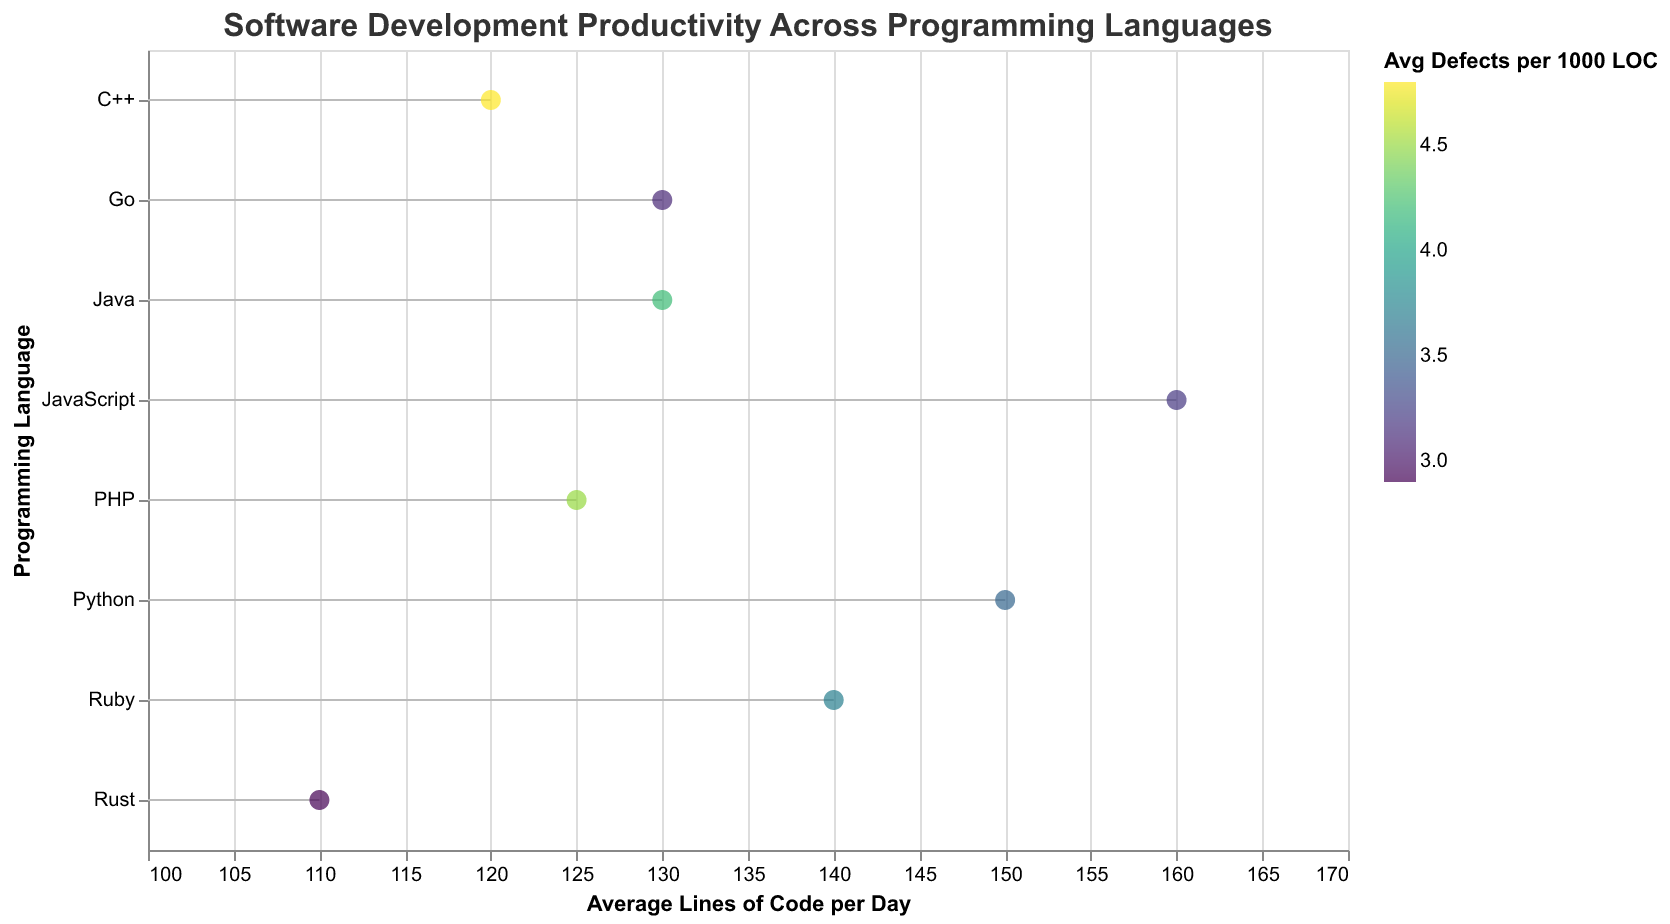What is the title of the plot? The title of the plot is usually found at the top of the figure. In this case, it is specified as "Software Development Productivity Across Programming Languages".
Answer: Software Development Productivity Across Programming Languages Which programming language has the highest average lines of code per day? From the plot, locate the programming language associated with the highest value on the x-axis ("Average Lines of Code per Day"). The highest value here is 160, which corresponds to JavaScript.
Answer: JavaScript Which programming language has the lowest average defects per 1000 lines of code? Look at the color legend associated with "Average Defects per 1000 Lines of Code" and find the programming language with the darkest color. Rust has the lowest defects at 2.9 per 1000 lines of code.
Answer: Rust What is the average years of experience for developers using Python? The years of experience for Python, provided in the tooltip, is 5 years.
Answer: 5 How does the productivity of Python developers compare to that of Java developers in terms of average lines of code per day? Compare the "Average Lines of Code per Day" for Python and Java by looking at their respective positions on the x-axis. Python developers have 150 lines per day, while Java developers have 130 lines per day.
Answer: Python developers are more productive with 150 lines per day compared to Java developers with 130 lines per day Which company shows the highest average lines of code per day among its developers, and what is the corresponding programming language? Look for the data point farthest to the right on the x-axis and refer to the tooltip to identify the related company and programming language. Amazon and JavaScript are associated with the highest productivity (160 lines per day).
Answer: Amazon, JavaScript What is the range of average lines of code per day across all programming languages? Identify the smallest and largest values on the x-axis for "Average Lines of Code per Day". The smallest value is 110 (Rust), and the largest value is 160 (JavaScript), so the range is 160 - 110 = 50.
Answer: 50 Which language has the highest defect rate, and what's the value? Check the color legend for the "Average Defects per 1000 Lines of Code" and identify the brightest data point, which is C++ with the value of 4.8.
Answer: C++ at 4.8 Between Go and PHP, which language has a higher average lines of code per day, and by how much? Compare the "Average Lines of Code per Day" for Go and PHP on the x-axis. Go has 130 lines per day and PHP has 125 lines per day, so Go has 130 - 125 = 5 more lines per day than PHP.
Answer: Go by 5 